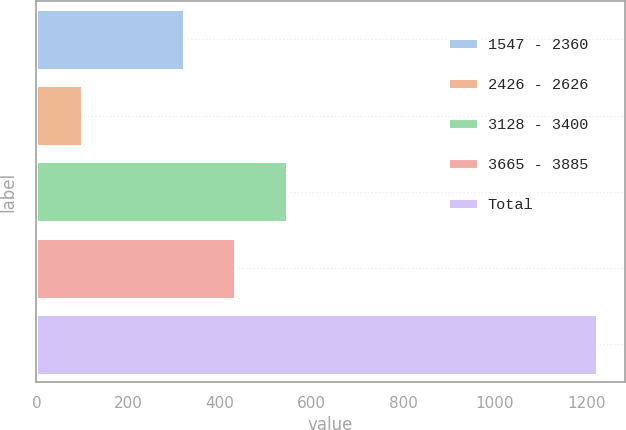Convert chart. <chart><loc_0><loc_0><loc_500><loc_500><bar_chart><fcel>1547 - 2360<fcel>2426 - 2626<fcel>3128 - 3400<fcel>3665 - 3885<fcel>Total<nl><fcel>322<fcel>100<fcel>546.4<fcel>434.2<fcel>1222<nl></chart> 